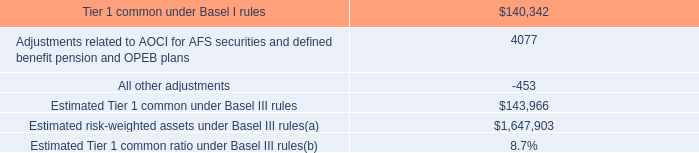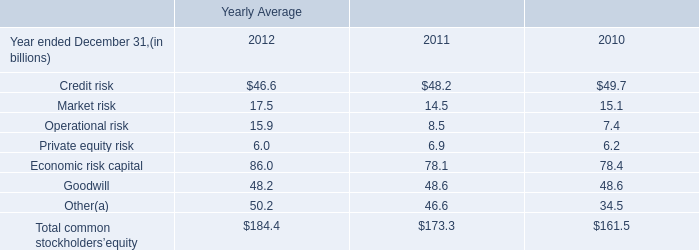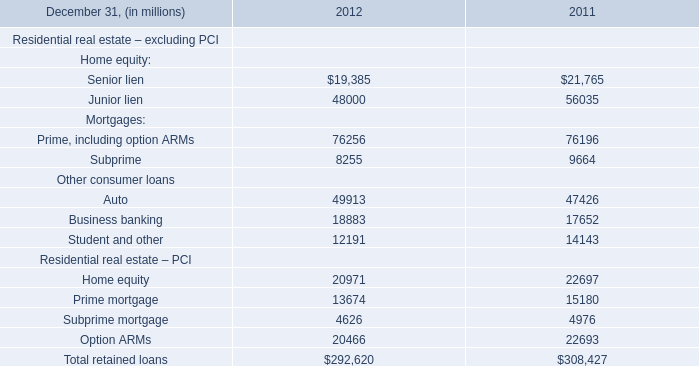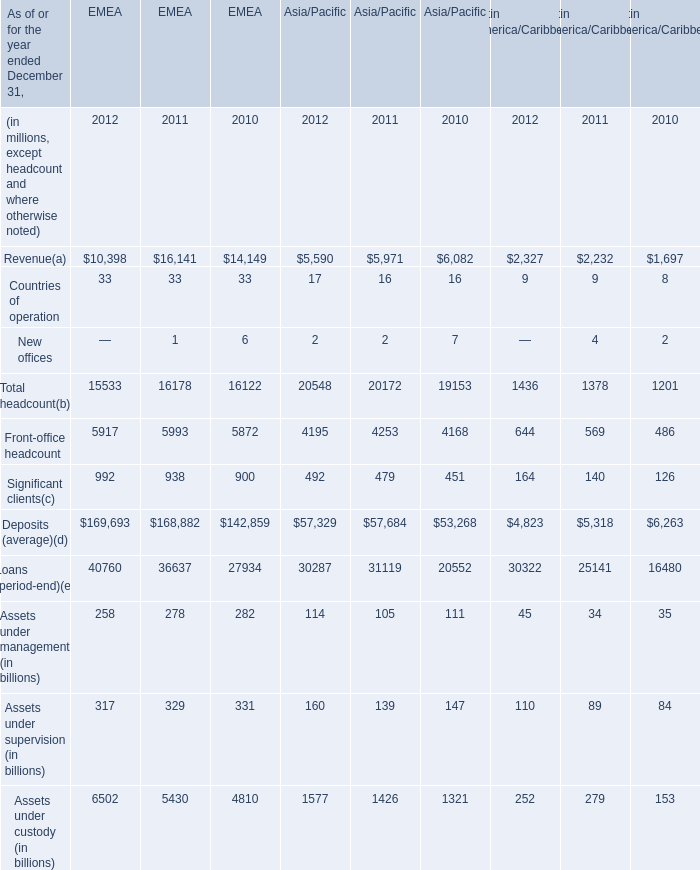In the section with the most Revenue, what is the growth rate of Significant clients? (in %) 
Computations: ((938 - 900) / 900)
Answer: 0.04222. 